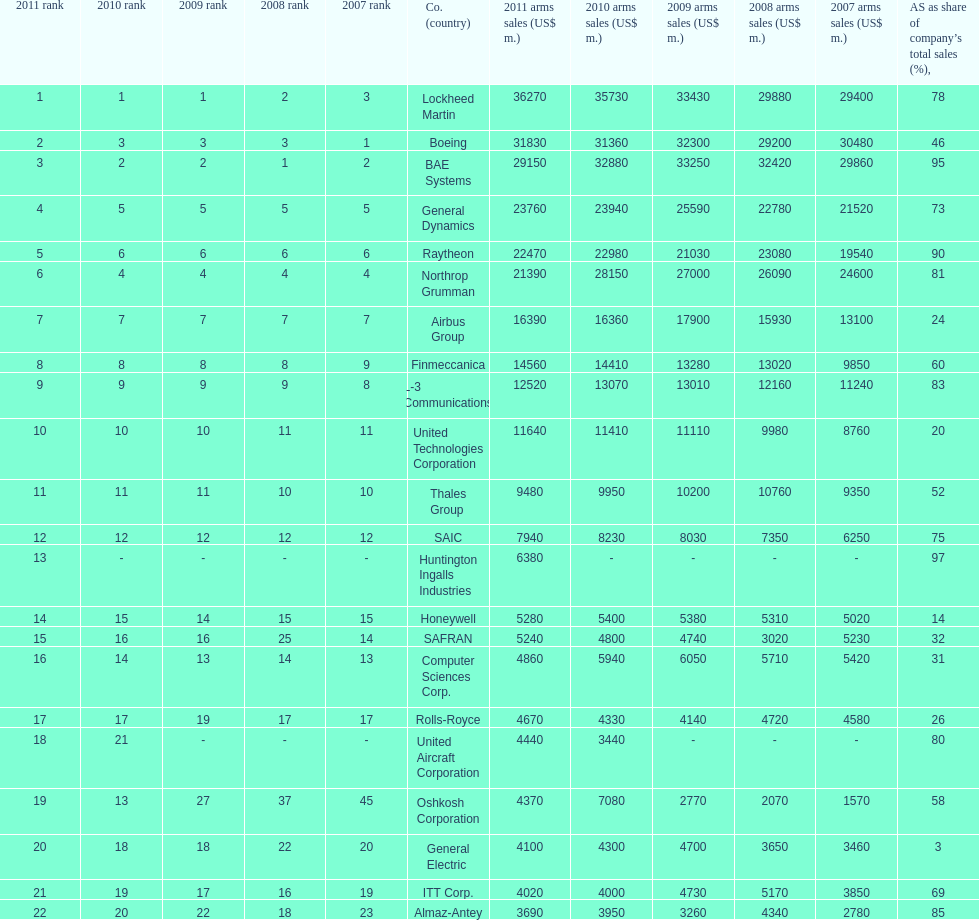What country is the first listed country? USA. 